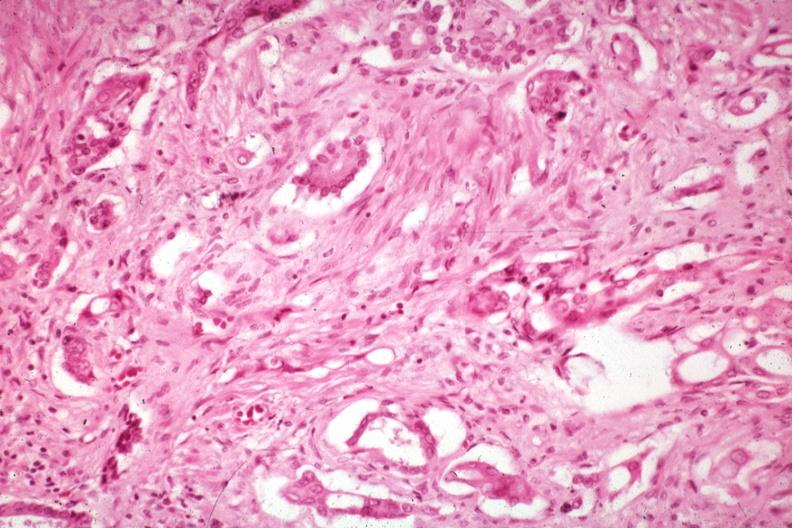what are anaplastic carcinoma with desmoplasia large myofibroblastic cell?
Answer the question using a single word or phrase. Prominent in the stroma 